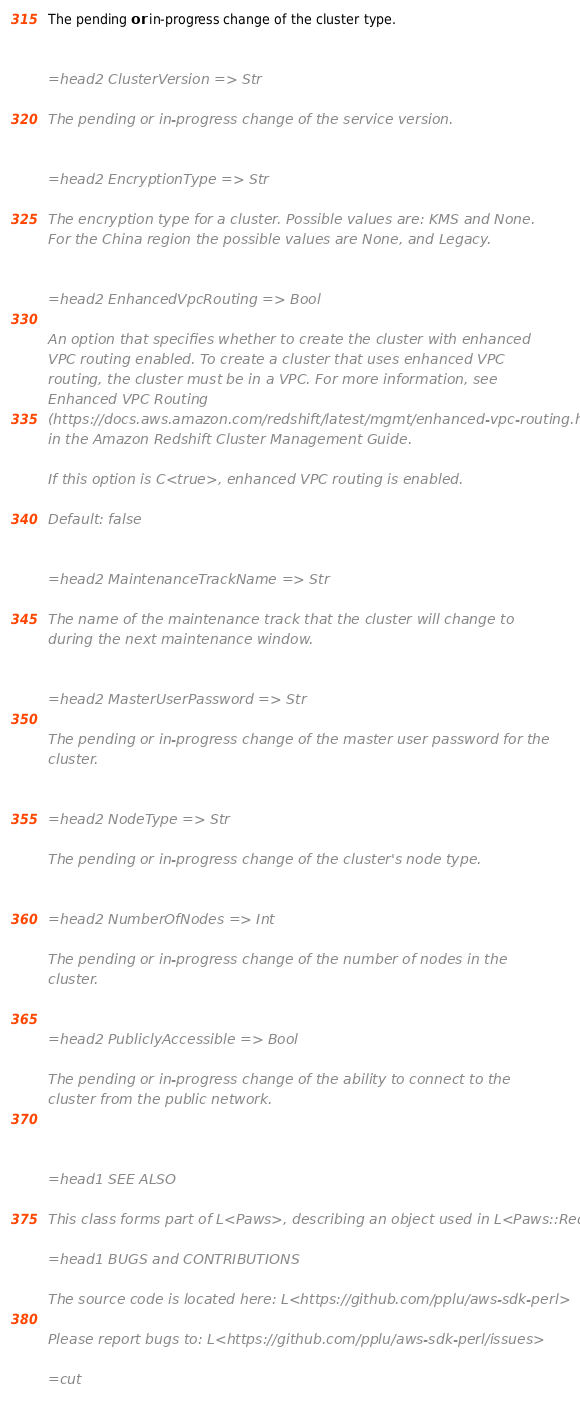<code> <loc_0><loc_0><loc_500><loc_500><_Perl_>
The pending or in-progress change of the cluster type.


=head2 ClusterVersion => Str

The pending or in-progress change of the service version.


=head2 EncryptionType => Str

The encryption type for a cluster. Possible values are: KMS and None.
For the China region the possible values are None, and Legacy.


=head2 EnhancedVpcRouting => Bool

An option that specifies whether to create the cluster with enhanced
VPC routing enabled. To create a cluster that uses enhanced VPC
routing, the cluster must be in a VPC. For more information, see
Enhanced VPC Routing
(https://docs.aws.amazon.com/redshift/latest/mgmt/enhanced-vpc-routing.html)
in the Amazon Redshift Cluster Management Guide.

If this option is C<true>, enhanced VPC routing is enabled.

Default: false


=head2 MaintenanceTrackName => Str

The name of the maintenance track that the cluster will change to
during the next maintenance window.


=head2 MasterUserPassword => Str

The pending or in-progress change of the master user password for the
cluster.


=head2 NodeType => Str

The pending or in-progress change of the cluster's node type.


=head2 NumberOfNodes => Int

The pending or in-progress change of the number of nodes in the
cluster.


=head2 PubliclyAccessible => Bool

The pending or in-progress change of the ability to connect to the
cluster from the public network.



=head1 SEE ALSO

This class forms part of L<Paws>, describing an object used in L<Paws::RedShift>

=head1 BUGS and CONTRIBUTIONS

The source code is located here: L<https://github.com/pplu/aws-sdk-perl>

Please report bugs to: L<https://github.com/pplu/aws-sdk-perl/issues>

=cut

</code> 